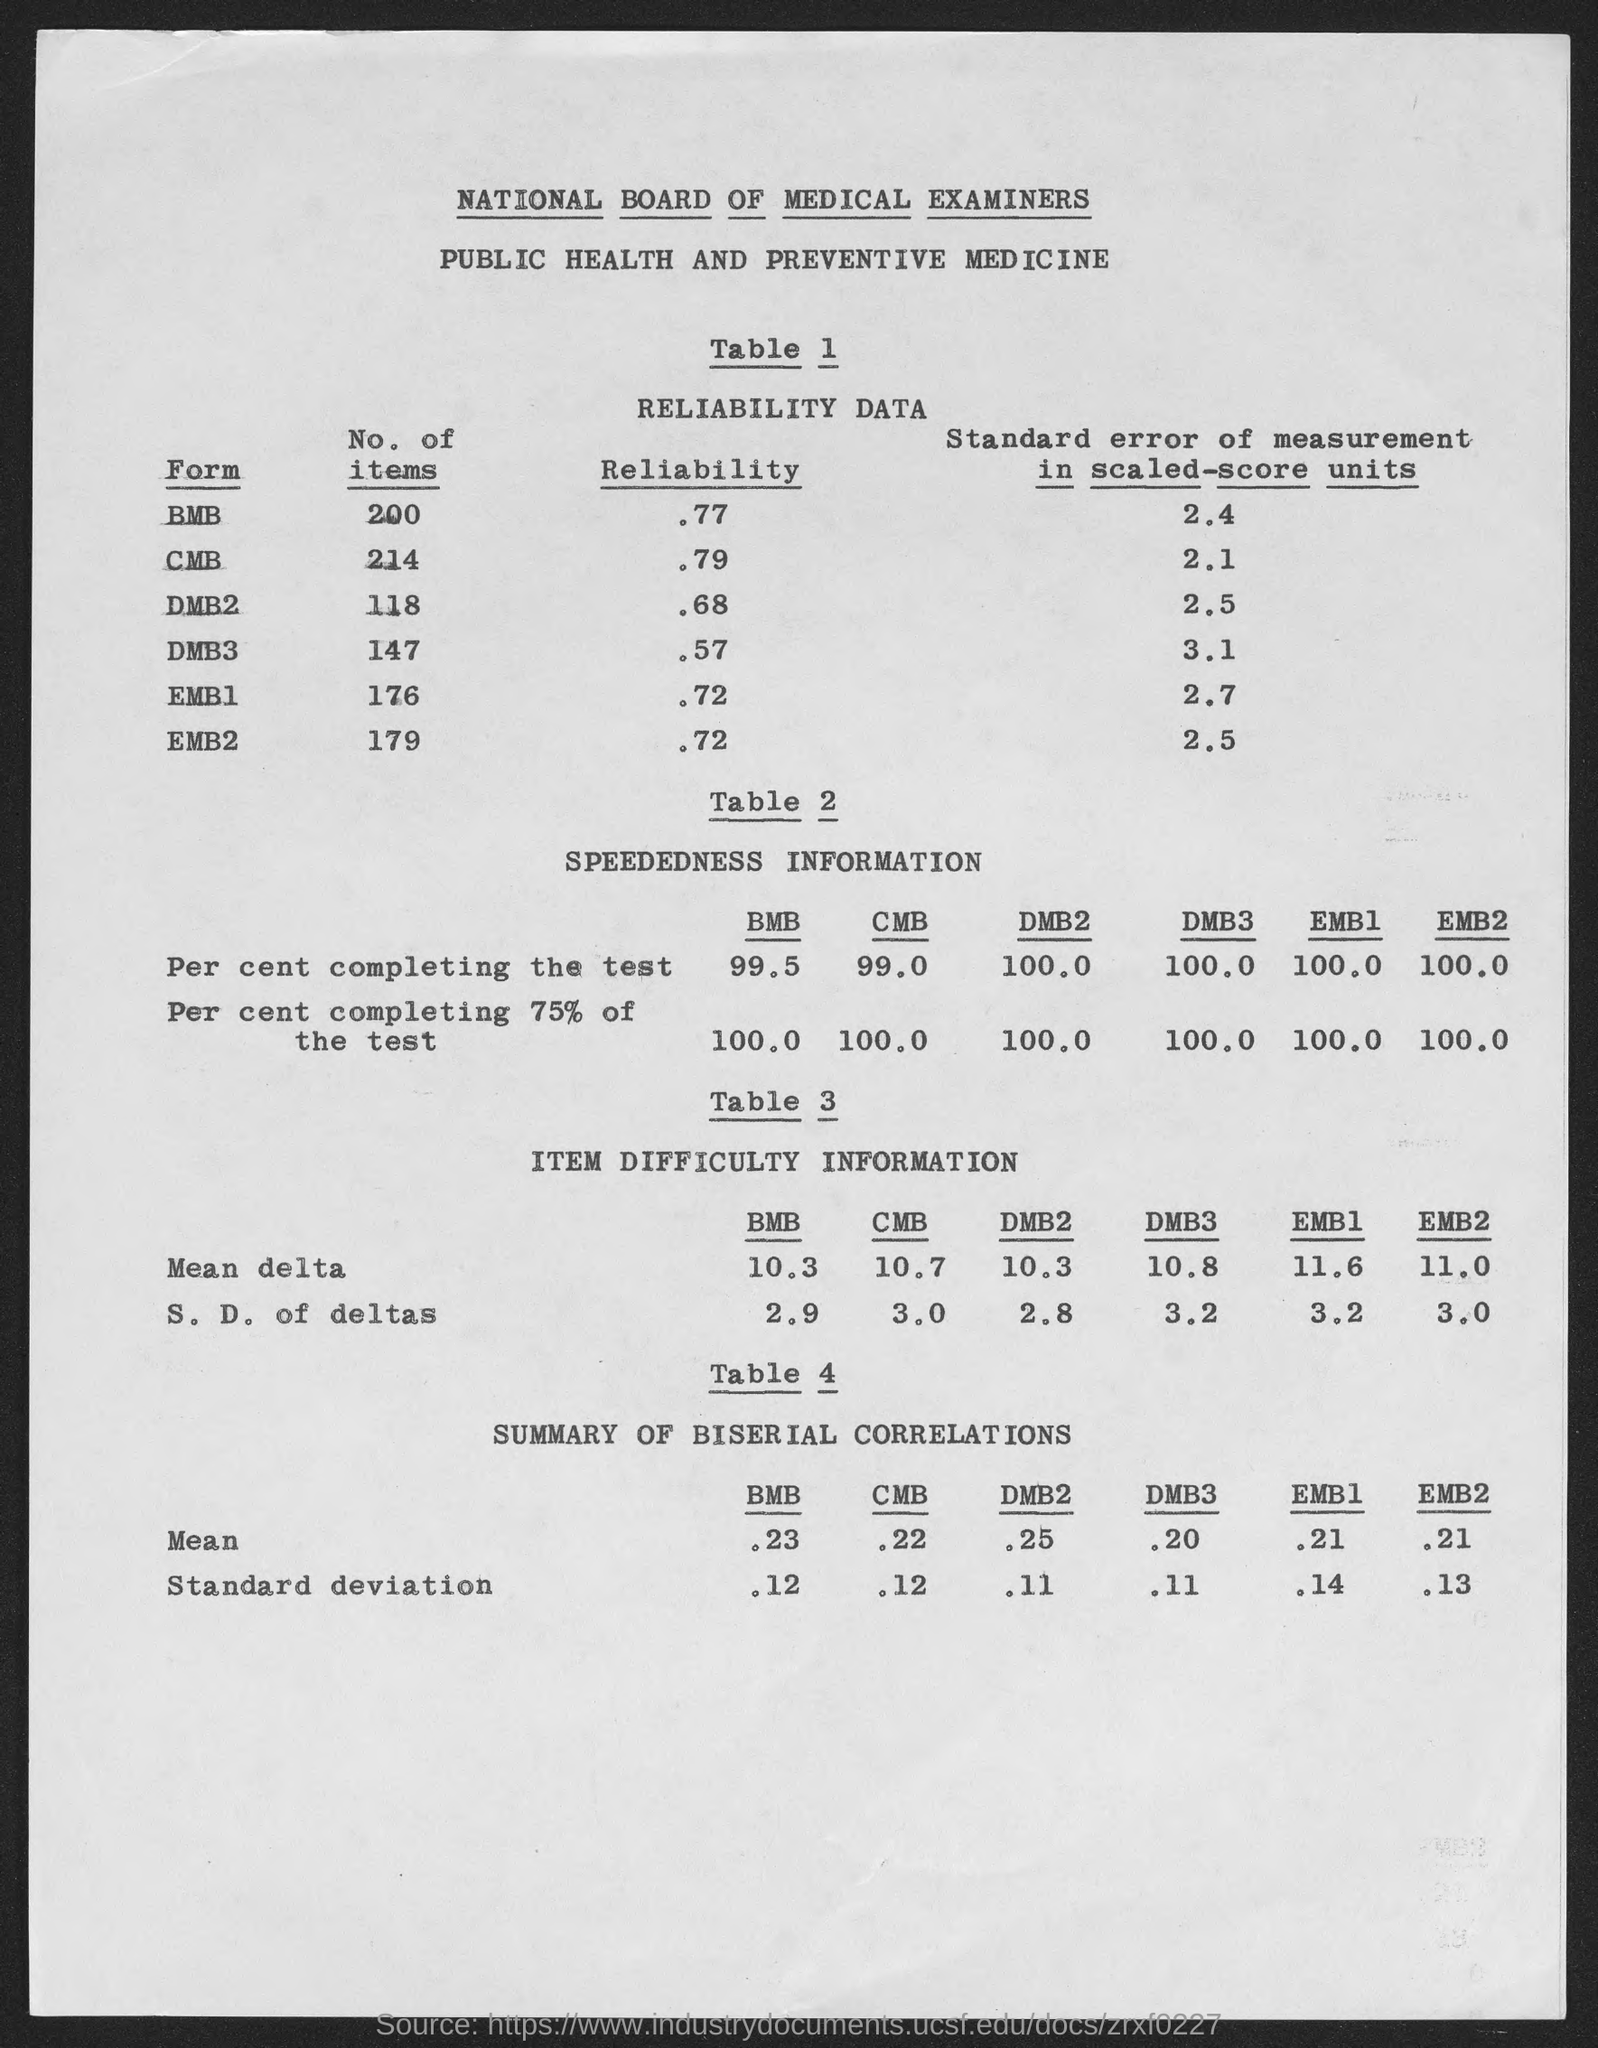List a handful of essential elements in this visual. Table 4 presents a summary of the biserial correlations between the scores on the ADHD RS and the scores on the ADHD-RS V. The table provides information on the strength and direction of the relationships between the two measures. ITEM DIFFICULTY INFORMATION is the title of Table 3. In the summary of biserial correlation in BMB column, the standard deviation value is 0.12. The standard deviation value for the biserial correlation in the DMB2 column is .11. The title of Table 1 is 'Reliability Data'. 